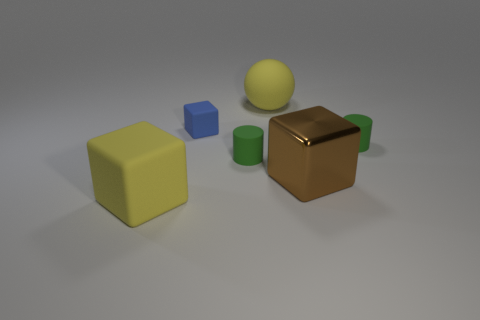Subtract all matte cubes. How many cubes are left? 1 Subtract 1 cylinders. How many cylinders are left? 1 Subtract all cyan cylinders. How many yellow blocks are left? 1 Subtract all cubes. Subtract all small cylinders. How many objects are left? 1 Add 2 small blue things. How many small blue things are left? 3 Add 6 small blue cylinders. How many small blue cylinders exist? 6 Add 3 tiny matte cylinders. How many objects exist? 9 Subtract 0 purple cylinders. How many objects are left? 6 Subtract all balls. How many objects are left? 5 Subtract all red spheres. Subtract all cyan blocks. How many spheres are left? 1 